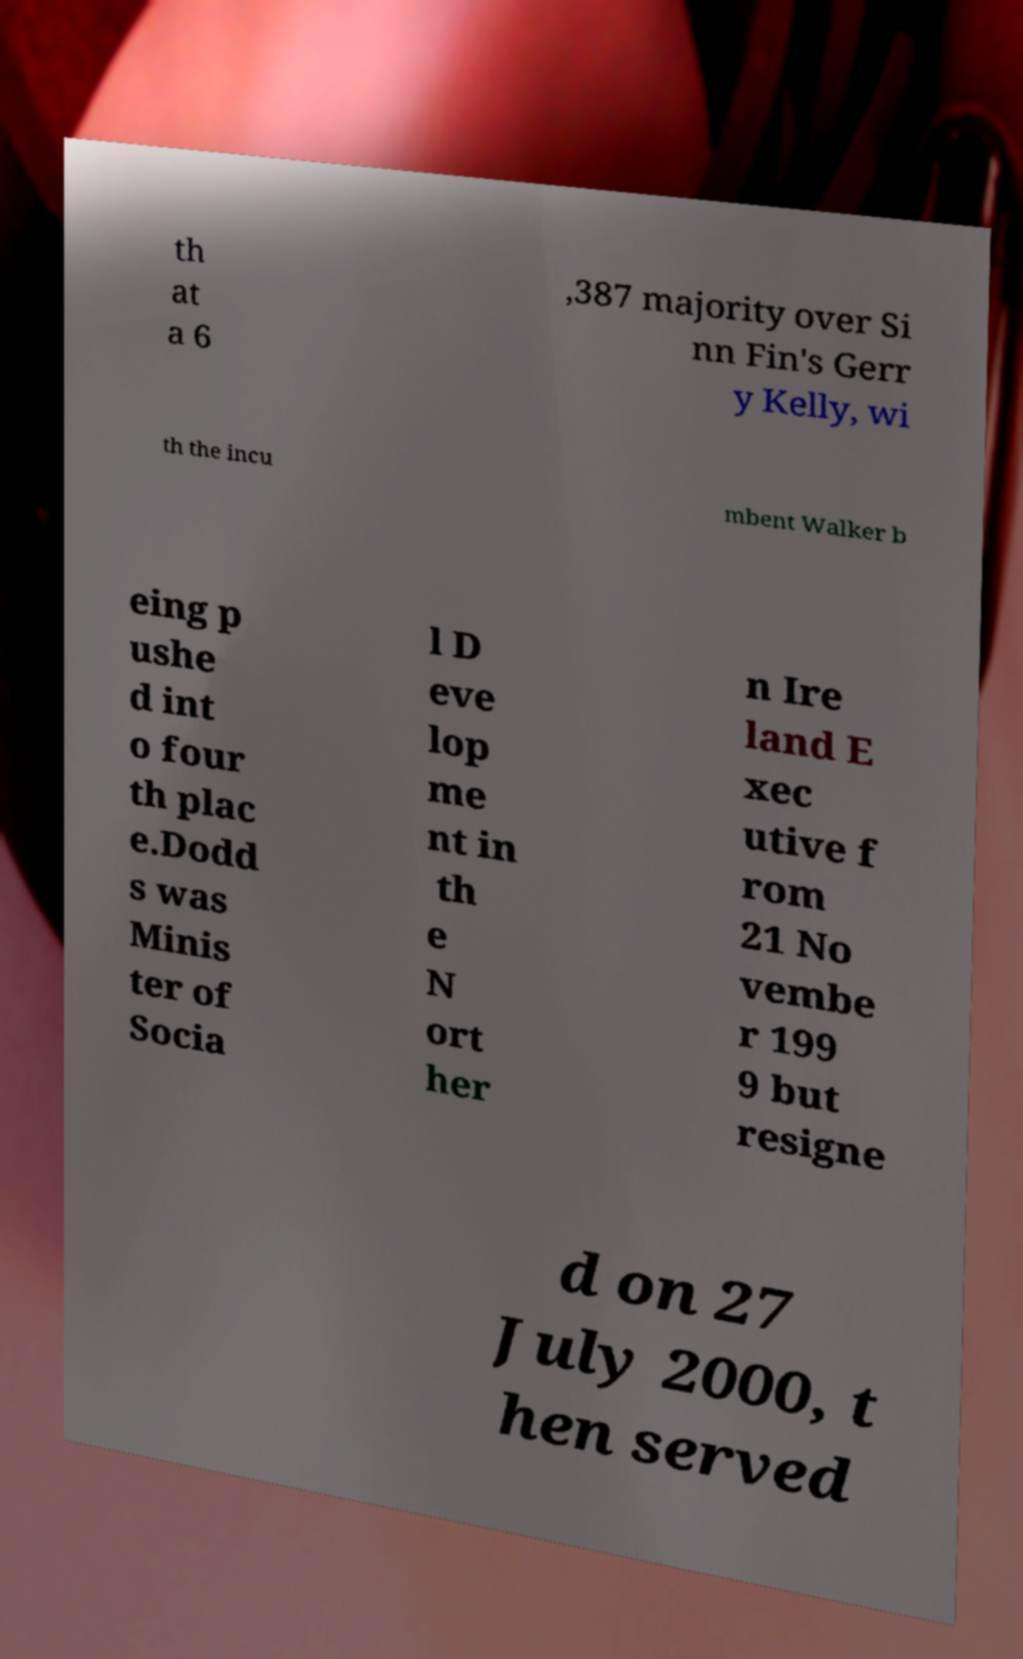Please read and relay the text visible in this image. What does it say? th at a 6 ,387 majority over Si nn Fin's Gerr y Kelly, wi th the incu mbent Walker b eing p ushe d int o four th plac e.Dodd s was Minis ter of Socia l D eve lop me nt in th e N ort her n Ire land E xec utive f rom 21 No vembe r 199 9 but resigne d on 27 July 2000, t hen served 